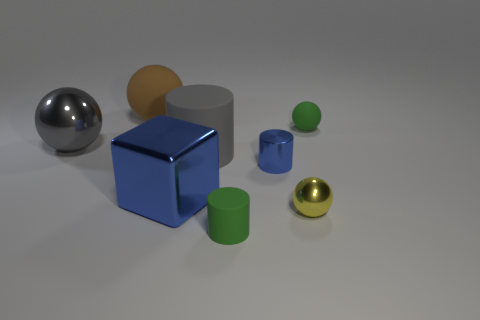There is a brown rubber object that is the same shape as the yellow thing; what size is it?
Give a very brief answer. Large. Is the material of the yellow sphere the same as the ball on the right side of the small yellow metal object?
Your answer should be very brief. No. There is a metal object that is on the right side of the big blue shiny object and behind the yellow metallic object; what shape is it?
Offer a terse response. Cylinder. What number of other things are there of the same color as the metallic cylinder?
Your response must be concise. 1. The tiny yellow metallic object has what shape?
Provide a short and direct response. Sphere. There is a matte ball to the right of the green object that is in front of the yellow metallic sphere; what color is it?
Provide a short and direct response. Green. Does the tiny rubber ball have the same color as the tiny rubber object in front of the large blue thing?
Keep it short and to the point. Yes. What is the material of the big object that is behind the blue metallic cube and on the right side of the big brown matte ball?
Your response must be concise. Rubber. Are there any cyan rubber cylinders that have the same size as the green cylinder?
Provide a short and direct response. No. What material is the green cylinder that is the same size as the yellow object?
Provide a short and direct response. Rubber. 